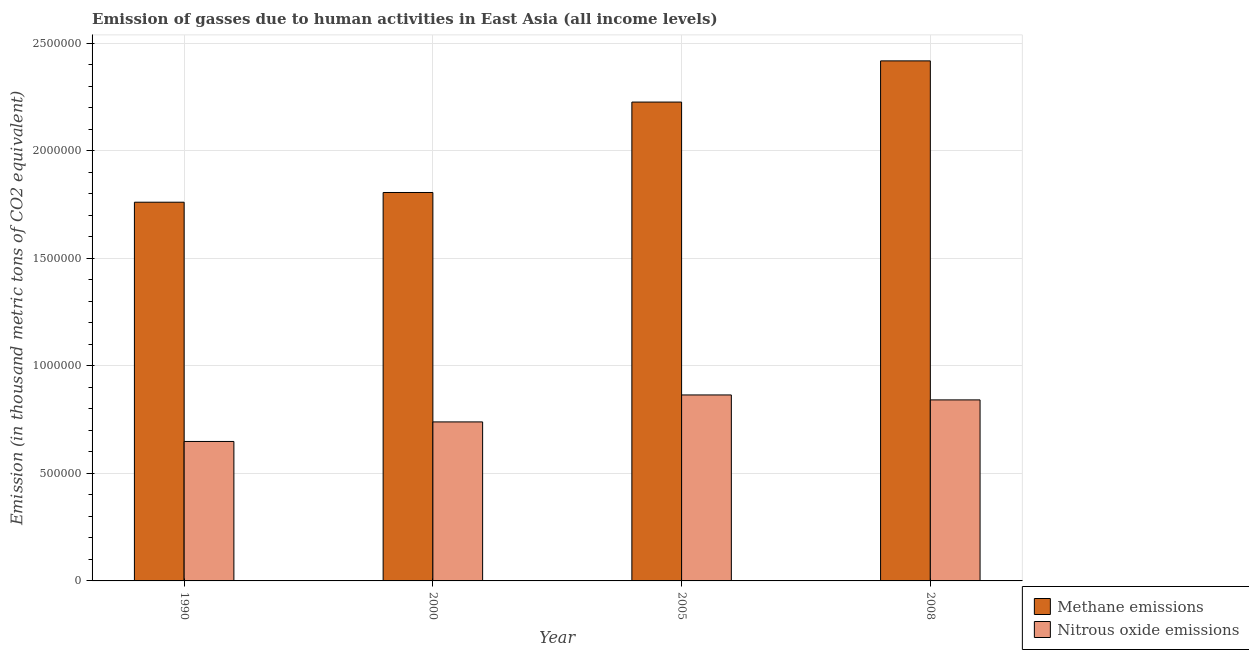How many bars are there on the 1st tick from the right?
Offer a terse response. 2. In how many cases, is the number of bars for a given year not equal to the number of legend labels?
Give a very brief answer. 0. What is the amount of nitrous oxide emissions in 2005?
Offer a terse response. 8.65e+05. Across all years, what is the maximum amount of methane emissions?
Make the answer very short. 2.42e+06. Across all years, what is the minimum amount of methane emissions?
Your answer should be compact. 1.76e+06. In which year was the amount of nitrous oxide emissions maximum?
Your response must be concise. 2005. What is the total amount of nitrous oxide emissions in the graph?
Provide a succinct answer. 3.09e+06. What is the difference between the amount of methane emissions in 1990 and that in 2008?
Your answer should be very brief. -6.57e+05. What is the difference between the amount of methane emissions in 1990 and the amount of nitrous oxide emissions in 2005?
Offer a terse response. -4.66e+05. What is the average amount of methane emissions per year?
Your response must be concise. 2.05e+06. In the year 1990, what is the difference between the amount of nitrous oxide emissions and amount of methane emissions?
Keep it short and to the point. 0. What is the ratio of the amount of methane emissions in 1990 to that in 2005?
Keep it short and to the point. 0.79. Is the amount of methane emissions in 1990 less than that in 2000?
Keep it short and to the point. Yes. What is the difference between the highest and the second highest amount of nitrous oxide emissions?
Provide a succinct answer. 2.30e+04. What is the difference between the highest and the lowest amount of nitrous oxide emissions?
Your answer should be very brief. 2.16e+05. In how many years, is the amount of methane emissions greater than the average amount of methane emissions taken over all years?
Provide a succinct answer. 2. Is the sum of the amount of nitrous oxide emissions in 1990 and 2008 greater than the maximum amount of methane emissions across all years?
Provide a succinct answer. Yes. What does the 1st bar from the left in 2008 represents?
Your answer should be compact. Methane emissions. What does the 2nd bar from the right in 2000 represents?
Provide a short and direct response. Methane emissions. Are all the bars in the graph horizontal?
Your answer should be compact. No. How many years are there in the graph?
Give a very brief answer. 4. What is the difference between two consecutive major ticks on the Y-axis?
Your answer should be very brief. 5.00e+05. Are the values on the major ticks of Y-axis written in scientific E-notation?
Offer a very short reply. No. Does the graph contain any zero values?
Your answer should be compact. No. Where does the legend appear in the graph?
Offer a terse response. Bottom right. How many legend labels are there?
Make the answer very short. 2. How are the legend labels stacked?
Provide a succinct answer. Vertical. What is the title of the graph?
Provide a short and direct response. Emission of gasses due to human activities in East Asia (all income levels). What is the label or title of the Y-axis?
Ensure brevity in your answer.  Emission (in thousand metric tons of CO2 equivalent). What is the Emission (in thousand metric tons of CO2 equivalent) of Methane emissions in 1990?
Ensure brevity in your answer.  1.76e+06. What is the Emission (in thousand metric tons of CO2 equivalent) of Nitrous oxide emissions in 1990?
Ensure brevity in your answer.  6.49e+05. What is the Emission (in thousand metric tons of CO2 equivalent) of Methane emissions in 2000?
Offer a very short reply. 1.81e+06. What is the Emission (in thousand metric tons of CO2 equivalent) of Nitrous oxide emissions in 2000?
Keep it short and to the point. 7.39e+05. What is the Emission (in thousand metric tons of CO2 equivalent) in Methane emissions in 2005?
Your response must be concise. 2.23e+06. What is the Emission (in thousand metric tons of CO2 equivalent) in Nitrous oxide emissions in 2005?
Make the answer very short. 8.65e+05. What is the Emission (in thousand metric tons of CO2 equivalent) of Methane emissions in 2008?
Make the answer very short. 2.42e+06. What is the Emission (in thousand metric tons of CO2 equivalent) of Nitrous oxide emissions in 2008?
Ensure brevity in your answer.  8.42e+05. Across all years, what is the maximum Emission (in thousand metric tons of CO2 equivalent) of Methane emissions?
Provide a short and direct response. 2.42e+06. Across all years, what is the maximum Emission (in thousand metric tons of CO2 equivalent) of Nitrous oxide emissions?
Provide a short and direct response. 8.65e+05. Across all years, what is the minimum Emission (in thousand metric tons of CO2 equivalent) in Methane emissions?
Ensure brevity in your answer.  1.76e+06. Across all years, what is the minimum Emission (in thousand metric tons of CO2 equivalent) of Nitrous oxide emissions?
Keep it short and to the point. 6.49e+05. What is the total Emission (in thousand metric tons of CO2 equivalent) in Methane emissions in the graph?
Your answer should be compact. 8.21e+06. What is the total Emission (in thousand metric tons of CO2 equivalent) in Nitrous oxide emissions in the graph?
Offer a very short reply. 3.09e+06. What is the difference between the Emission (in thousand metric tons of CO2 equivalent) of Methane emissions in 1990 and that in 2000?
Provide a short and direct response. -4.52e+04. What is the difference between the Emission (in thousand metric tons of CO2 equivalent) in Nitrous oxide emissions in 1990 and that in 2000?
Offer a very short reply. -9.09e+04. What is the difference between the Emission (in thousand metric tons of CO2 equivalent) of Methane emissions in 1990 and that in 2005?
Make the answer very short. -4.66e+05. What is the difference between the Emission (in thousand metric tons of CO2 equivalent) of Nitrous oxide emissions in 1990 and that in 2005?
Keep it short and to the point. -2.16e+05. What is the difference between the Emission (in thousand metric tons of CO2 equivalent) of Methane emissions in 1990 and that in 2008?
Provide a short and direct response. -6.57e+05. What is the difference between the Emission (in thousand metric tons of CO2 equivalent) in Nitrous oxide emissions in 1990 and that in 2008?
Your answer should be compact. -1.93e+05. What is the difference between the Emission (in thousand metric tons of CO2 equivalent) in Methane emissions in 2000 and that in 2005?
Offer a terse response. -4.20e+05. What is the difference between the Emission (in thousand metric tons of CO2 equivalent) in Nitrous oxide emissions in 2000 and that in 2005?
Offer a terse response. -1.25e+05. What is the difference between the Emission (in thousand metric tons of CO2 equivalent) of Methane emissions in 2000 and that in 2008?
Offer a very short reply. -6.12e+05. What is the difference between the Emission (in thousand metric tons of CO2 equivalent) of Nitrous oxide emissions in 2000 and that in 2008?
Give a very brief answer. -1.02e+05. What is the difference between the Emission (in thousand metric tons of CO2 equivalent) in Methane emissions in 2005 and that in 2008?
Make the answer very short. -1.92e+05. What is the difference between the Emission (in thousand metric tons of CO2 equivalent) of Nitrous oxide emissions in 2005 and that in 2008?
Provide a short and direct response. 2.30e+04. What is the difference between the Emission (in thousand metric tons of CO2 equivalent) of Methane emissions in 1990 and the Emission (in thousand metric tons of CO2 equivalent) of Nitrous oxide emissions in 2000?
Your answer should be very brief. 1.02e+06. What is the difference between the Emission (in thousand metric tons of CO2 equivalent) of Methane emissions in 1990 and the Emission (in thousand metric tons of CO2 equivalent) of Nitrous oxide emissions in 2005?
Keep it short and to the point. 8.96e+05. What is the difference between the Emission (in thousand metric tons of CO2 equivalent) of Methane emissions in 1990 and the Emission (in thousand metric tons of CO2 equivalent) of Nitrous oxide emissions in 2008?
Give a very brief answer. 9.19e+05. What is the difference between the Emission (in thousand metric tons of CO2 equivalent) in Methane emissions in 2000 and the Emission (in thousand metric tons of CO2 equivalent) in Nitrous oxide emissions in 2005?
Your answer should be very brief. 9.42e+05. What is the difference between the Emission (in thousand metric tons of CO2 equivalent) in Methane emissions in 2000 and the Emission (in thousand metric tons of CO2 equivalent) in Nitrous oxide emissions in 2008?
Provide a succinct answer. 9.65e+05. What is the difference between the Emission (in thousand metric tons of CO2 equivalent) of Methane emissions in 2005 and the Emission (in thousand metric tons of CO2 equivalent) of Nitrous oxide emissions in 2008?
Provide a short and direct response. 1.38e+06. What is the average Emission (in thousand metric tons of CO2 equivalent) in Methane emissions per year?
Offer a very short reply. 2.05e+06. What is the average Emission (in thousand metric tons of CO2 equivalent) of Nitrous oxide emissions per year?
Offer a terse response. 7.74e+05. In the year 1990, what is the difference between the Emission (in thousand metric tons of CO2 equivalent) in Methane emissions and Emission (in thousand metric tons of CO2 equivalent) in Nitrous oxide emissions?
Your response must be concise. 1.11e+06. In the year 2000, what is the difference between the Emission (in thousand metric tons of CO2 equivalent) of Methane emissions and Emission (in thousand metric tons of CO2 equivalent) of Nitrous oxide emissions?
Provide a succinct answer. 1.07e+06. In the year 2005, what is the difference between the Emission (in thousand metric tons of CO2 equivalent) of Methane emissions and Emission (in thousand metric tons of CO2 equivalent) of Nitrous oxide emissions?
Your response must be concise. 1.36e+06. In the year 2008, what is the difference between the Emission (in thousand metric tons of CO2 equivalent) of Methane emissions and Emission (in thousand metric tons of CO2 equivalent) of Nitrous oxide emissions?
Offer a very short reply. 1.58e+06. What is the ratio of the Emission (in thousand metric tons of CO2 equivalent) in Methane emissions in 1990 to that in 2000?
Offer a terse response. 0.97. What is the ratio of the Emission (in thousand metric tons of CO2 equivalent) in Nitrous oxide emissions in 1990 to that in 2000?
Offer a very short reply. 0.88. What is the ratio of the Emission (in thousand metric tons of CO2 equivalent) of Methane emissions in 1990 to that in 2005?
Keep it short and to the point. 0.79. What is the ratio of the Emission (in thousand metric tons of CO2 equivalent) of Nitrous oxide emissions in 1990 to that in 2005?
Ensure brevity in your answer.  0.75. What is the ratio of the Emission (in thousand metric tons of CO2 equivalent) of Methane emissions in 1990 to that in 2008?
Make the answer very short. 0.73. What is the ratio of the Emission (in thousand metric tons of CO2 equivalent) of Nitrous oxide emissions in 1990 to that in 2008?
Your answer should be compact. 0.77. What is the ratio of the Emission (in thousand metric tons of CO2 equivalent) of Methane emissions in 2000 to that in 2005?
Provide a short and direct response. 0.81. What is the ratio of the Emission (in thousand metric tons of CO2 equivalent) of Nitrous oxide emissions in 2000 to that in 2005?
Offer a terse response. 0.85. What is the ratio of the Emission (in thousand metric tons of CO2 equivalent) of Methane emissions in 2000 to that in 2008?
Keep it short and to the point. 0.75. What is the ratio of the Emission (in thousand metric tons of CO2 equivalent) of Nitrous oxide emissions in 2000 to that in 2008?
Ensure brevity in your answer.  0.88. What is the ratio of the Emission (in thousand metric tons of CO2 equivalent) of Methane emissions in 2005 to that in 2008?
Keep it short and to the point. 0.92. What is the ratio of the Emission (in thousand metric tons of CO2 equivalent) of Nitrous oxide emissions in 2005 to that in 2008?
Your response must be concise. 1.03. What is the difference between the highest and the second highest Emission (in thousand metric tons of CO2 equivalent) of Methane emissions?
Make the answer very short. 1.92e+05. What is the difference between the highest and the second highest Emission (in thousand metric tons of CO2 equivalent) in Nitrous oxide emissions?
Your answer should be very brief. 2.30e+04. What is the difference between the highest and the lowest Emission (in thousand metric tons of CO2 equivalent) of Methane emissions?
Offer a terse response. 6.57e+05. What is the difference between the highest and the lowest Emission (in thousand metric tons of CO2 equivalent) in Nitrous oxide emissions?
Ensure brevity in your answer.  2.16e+05. 